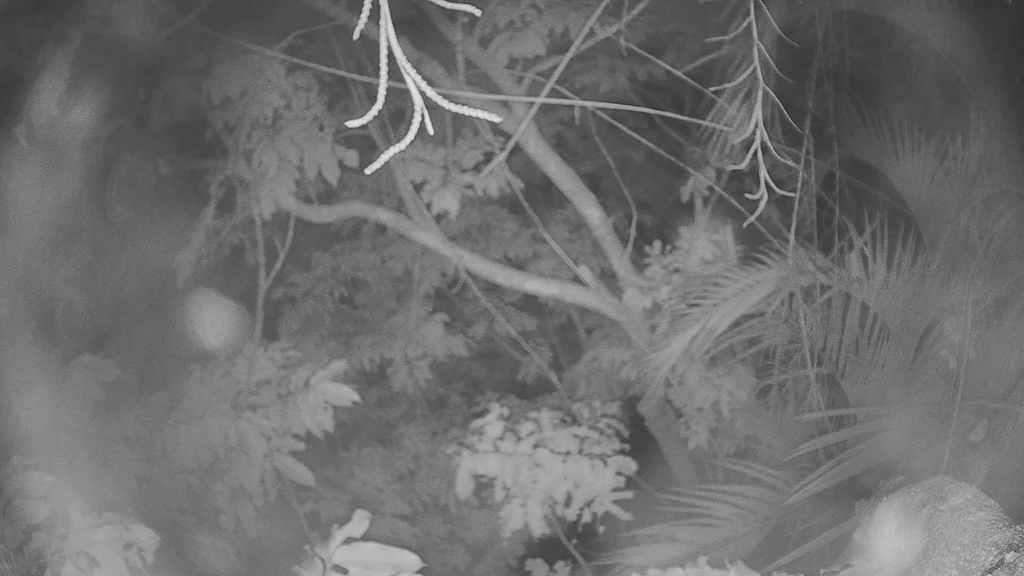Could you give a brief overview of what you see in this image? In this image I can see tree branches and leaves. I can also see this image is black and white in colour. 